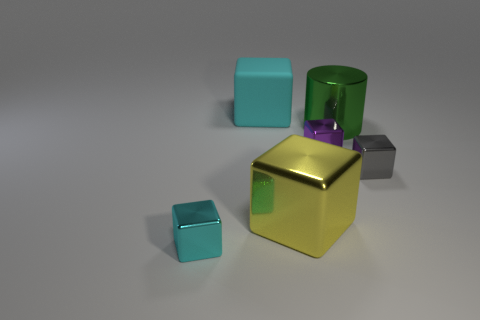Subtract all cyan cubes. How many were subtracted if there are1cyan cubes left? 1 Subtract all blue spheres. How many cyan cubes are left? 2 Subtract all big metallic cubes. How many cubes are left? 4 Subtract all cyan cubes. How many cubes are left? 3 Add 3 cyan rubber cubes. How many objects exist? 9 Subtract all blue cubes. Subtract all brown spheres. How many cubes are left? 5 Subtract all cylinders. How many objects are left? 5 Subtract all large things. Subtract all brown matte blocks. How many objects are left? 3 Add 6 large cyan cubes. How many large cyan cubes are left? 7 Add 6 purple balls. How many purple balls exist? 6 